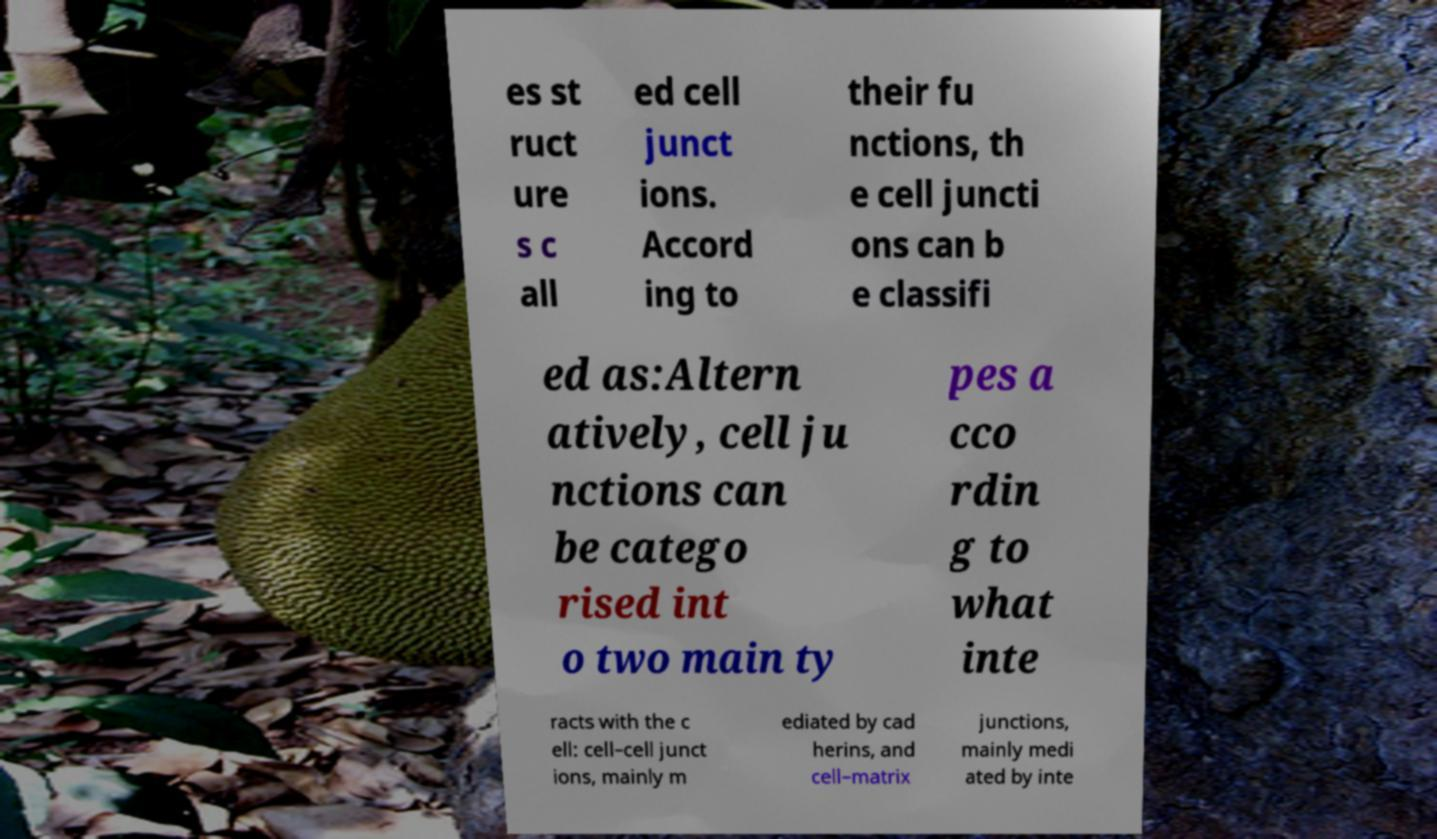Can you read and provide the text displayed in the image?This photo seems to have some interesting text. Can you extract and type it out for me? es st ruct ure s c all ed cell junct ions. Accord ing to their fu nctions, th e cell juncti ons can b e classifi ed as:Altern atively, cell ju nctions can be catego rised int o two main ty pes a cco rdin g to what inte racts with the c ell: cell–cell junct ions, mainly m ediated by cad herins, and cell–matrix junctions, mainly medi ated by inte 